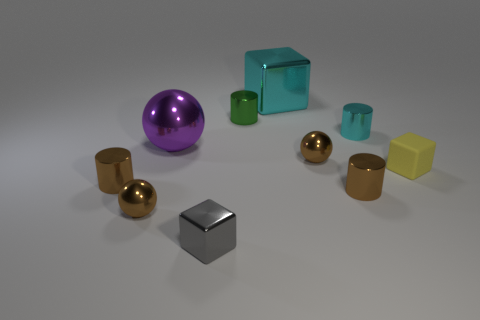What number of other things are there of the same color as the tiny rubber thing?
Your answer should be very brief. 0. Are there fewer tiny cyan things that are to the left of the small metal block than small cyan rubber cylinders?
Ensure brevity in your answer.  No. How many cyan blocks are there?
Give a very brief answer. 1. What number of tiny gray blocks are the same material as the small cyan cylinder?
Provide a succinct answer. 1. What number of things are either metal things that are in front of the large purple sphere or tiny gray shiny cubes?
Provide a short and direct response. 5. Is the number of small yellow cubes that are on the left side of the yellow cube less than the number of large things that are behind the small cyan metallic cylinder?
Offer a terse response. Yes. Are there any tiny yellow matte objects on the right side of the tiny gray cube?
Provide a succinct answer. Yes. What number of things are either shiny blocks that are in front of the cyan metallic cylinder or gray things to the left of the yellow matte thing?
Provide a short and direct response. 1. What number of small things are the same color as the large metallic block?
Keep it short and to the point. 1. The big thing that is the same shape as the small gray thing is what color?
Your response must be concise. Cyan. 